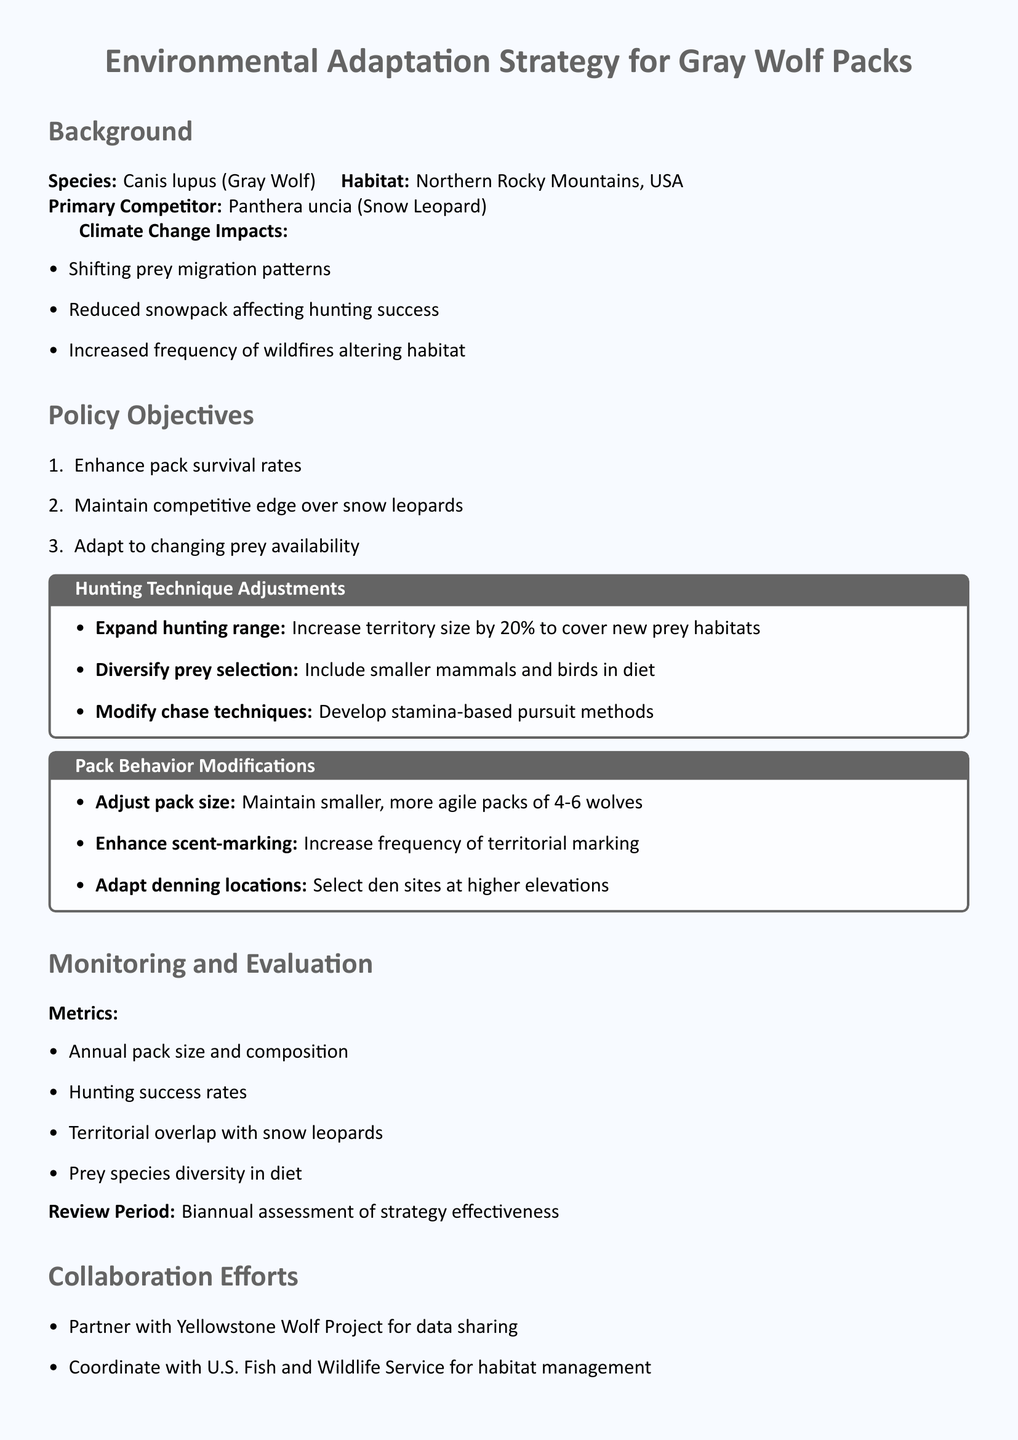What is the primary competitor of gray wolves? The document states that the primary competitor of gray wolves is the snow leopard.
Answer: Snow Leopard What are the three climate change impacts mentioned? The document lists shifting prey migration patterns, reduced snowpack affecting hunting success, and increased frequency of wildfires altering habitat as climate change impacts.
Answer: Shifting prey migration patterns, reduced snowpack, increased wildfires By what percentage should the hunting range be expanded? The document indicates that the hunting range should be increased by 20 percent to cover new prey habitats.
Answer: 20% What is the recommended pack size for gray wolves? According to the document, the recommended pack size is 4-6 wolves.
Answer: 4-6 wolves What is one objective of the policy? The document lists enhancing pack survival rates as one of the policy objectives.
Answer: Enhance pack survival rates What type of techniques are suggested to modify hunting methods? The document recommends developing stamina-based pursuit methods as a technique to modify hunting methods.
Answer: Stamina-based pursuit methods How often should the strategy be assessed? The document specifies that the strategy should be reviewed biannually.
Answer: Biannual Which organization is mentioned for data sharing? The document states that the Yellowstone Wolf Project is mentioned for data sharing.
Answer: Yellowstone Wolf Project What prey selection adjustment is recommended? The document advises diversifying prey selection to include smaller mammals and birds in the diet.
Answer: Include smaller mammals and birds 